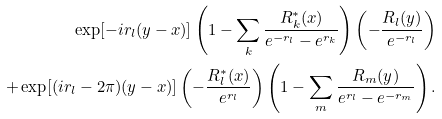<formula> <loc_0><loc_0><loc_500><loc_500>\exp [ - i r _ { l } ( y - x ) ] \left ( 1 - \sum _ { k } \frac { R _ { k } ^ { * } ( x ) } { e ^ { - r _ { l } } - e ^ { r _ { k } } } \right ) \left ( - \frac { R _ { l } ( y ) } { e ^ { - r _ { l } } } \right ) \\ + \exp [ ( i r _ { l } - 2 \pi ) ( y - x ) ] \left ( - \frac { R _ { l } ^ { * } ( x ) } { e ^ { r _ { l } } } \right ) \left ( 1 - \sum _ { m } \frac { R _ { m } ( y ) } { e ^ { r _ { l } } - e ^ { - r _ { m } } } \right ) .</formula> 